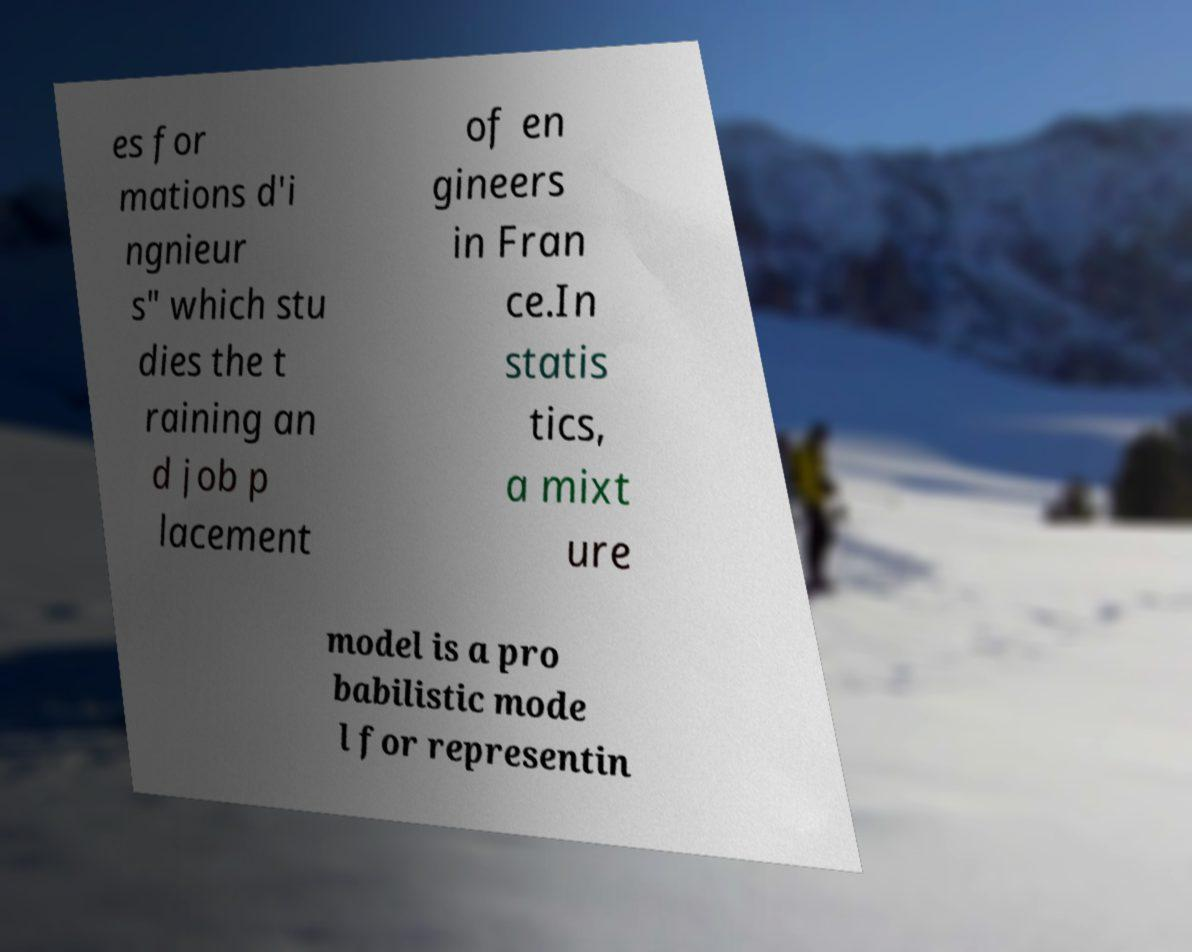For documentation purposes, I need the text within this image transcribed. Could you provide that? es for mations d'i ngnieur s" which stu dies the t raining an d job p lacement of en gineers in Fran ce.In statis tics, a mixt ure model is a pro babilistic mode l for representin 